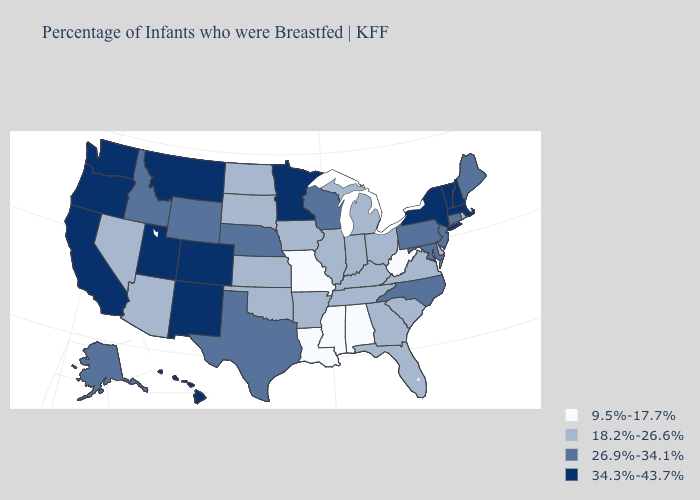Which states hav the highest value in the MidWest?
Be succinct. Minnesota. Name the states that have a value in the range 9.5%-17.7%?
Quick response, please. Alabama, Louisiana, Mississippi, Missouri, West Virginia. Does the map have missing data?
Quick response, please. No. What is the highest value in states that border South Dakota?
Give a very brief answer. 34.3%-43.7%. Does New York have a higher value than Texas?
Concise answer only. Yes. Name the states that have a value in the range 34.3%-43.7%?
Answer briefly. California, Colorado, Hawaii, Massachusetts, Minnesota, Montana, New Hampshire, New Mexico, New York, Oregon, Utah, Vermont, Washington. Among the states that border New Mexico , which have the lowest value?
Keep it brief. Arizona, Oklahoma. What is the value of Maryland?
Keep it brief. 26.9%-34.1%. What is the value of Wyoming?
Answer briefly. 26.9%-34.1%. Name the states that have a value in the range 18.2%-26.6%?
Short answer required. Arizona, Arkansas, Delaware, Florida, Georgia, Illinois, Indiana, Iowa, Kansas, Kentucky, Michigan, Nevada, North Dakota, Ohio, Oklahoma, Rhode Island, South Carolina, South Dakota, Tennessee, Virginia. Name the states that have a value in the range 9.5%-17.7%?
Write a very short answer. Alabama, Louisiana, Mississippi, Missouri, West Virginia. Which states hav the highest value in the MidWest?
Write a very short answer. Minnesota. What is the highest value in states that border Arkansas?
Answer briefly. 26.9%-34.1%. What is the value of Arkansas?
Answer briefly. 18.2%-26.6%. 